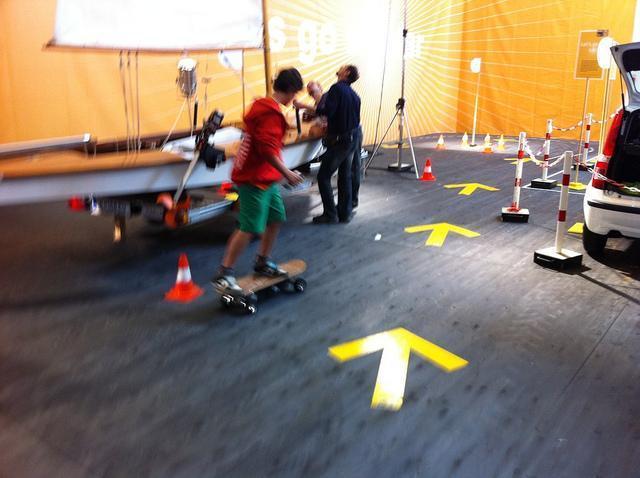How many cars are there?
Give a very brief answer. 1. How many people are there?
Give a very brief answer. 2. 